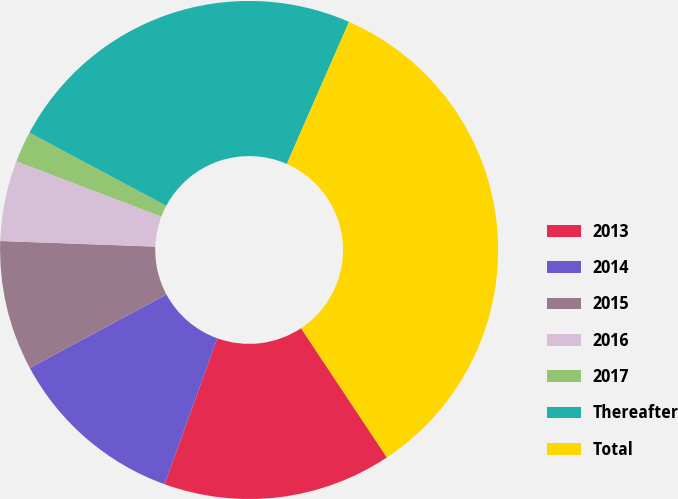Convert chart. <chart><loc_0><loc_0><loc_500><loc_500><pie_chart><fcel>2013<fcel>2014<fcel>2015<fcel>2016<fcel>2017<fcel>Thereafter<fcel>Total<nl><fcel>14.84%<fcel>11.64%<fcel>8.43%<fcel>5.22%<fcel>2.01%<fcel>23.77%<fcel>34.1%<nl></chart> 